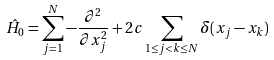Convert formula to latex. <formula><loc_0><loc_0><loc_500><loc_500>\hat { H } _ { 0 } = \sum _ { j = 1 } ^ { N } - \frac { \partial ^ { 2 } } { \partial x _ { j } ^ { 2 } } + 2 c \sum _ { 1 \leq j < k \leq N } \delta ( x _ { j } - x _ { k } )</formula> 